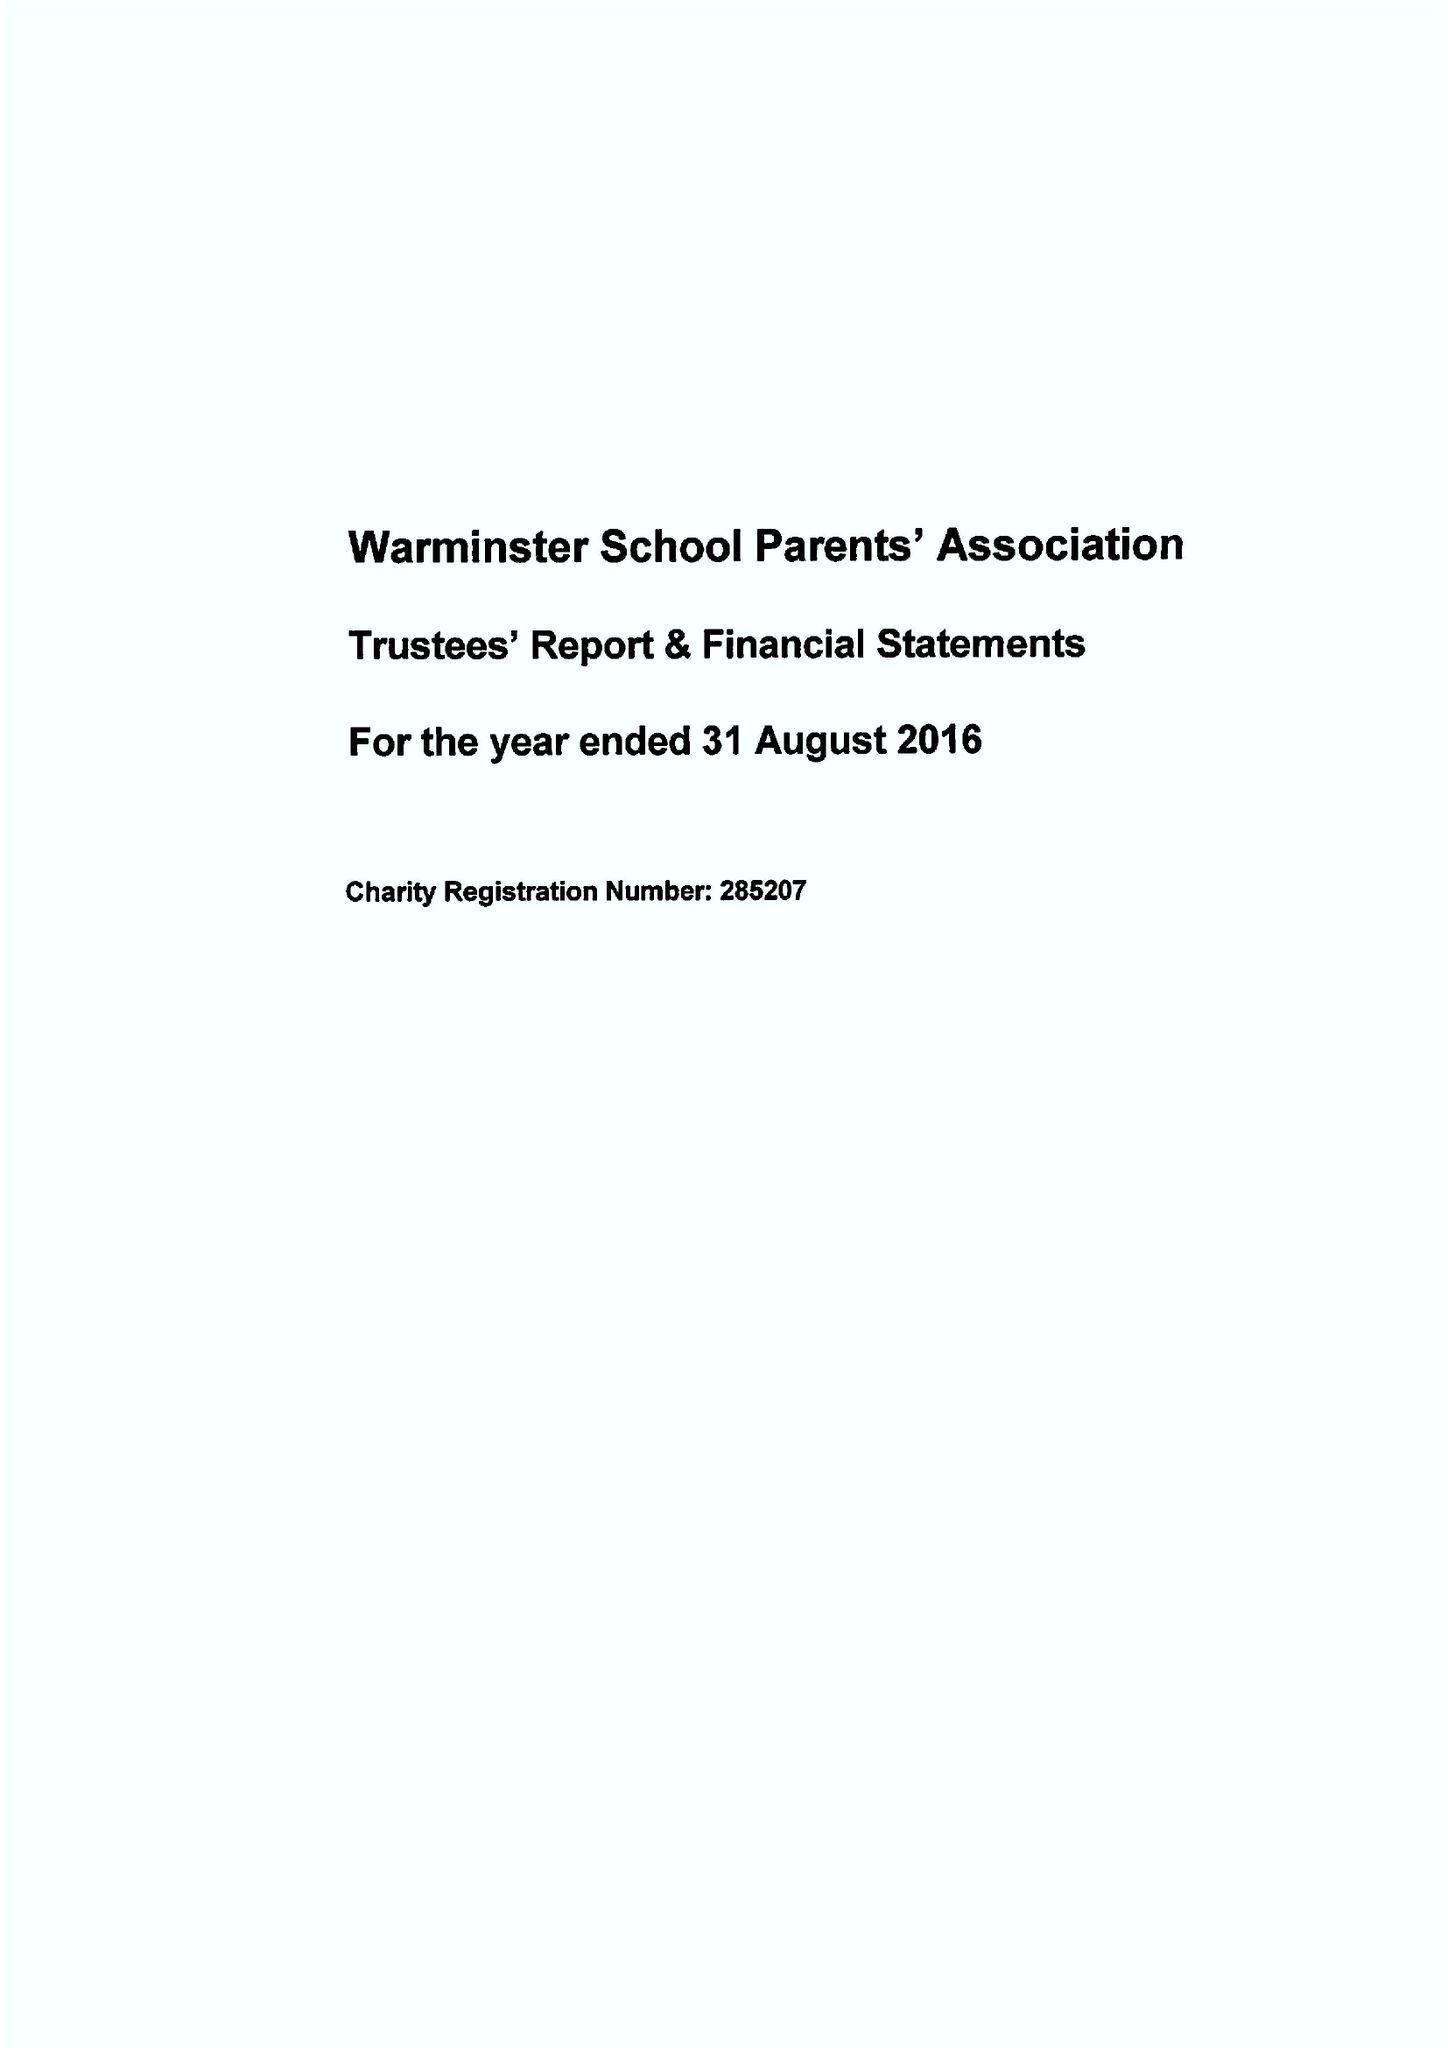What is the value for the address__street_line?
Answer the question using a single word or phrase. CHURCH STREET 